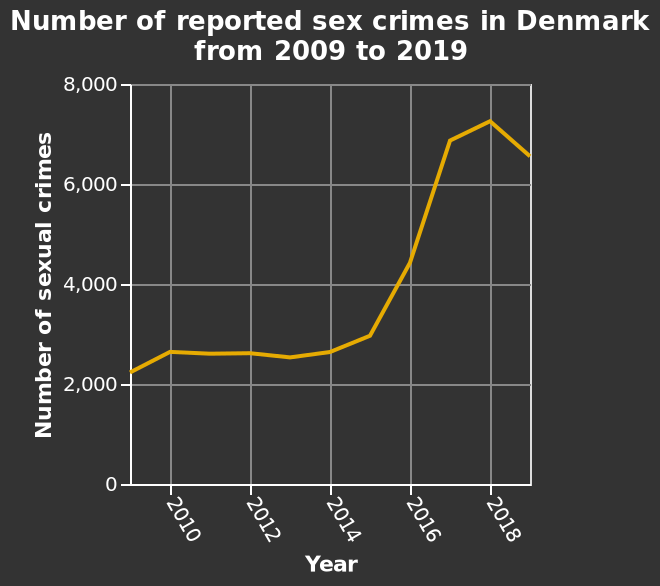<image>
Offer a thorough analysis of the image. There was a moderate increase in sex crimes reported in 2010. Numbers remained stable until 2014, where they saw a slight increase. 2026 and 2017 both saw large increases. A more moderate increase was reported in 2018. In 2019 the number of sex crimes reported saw a slight decrease. 